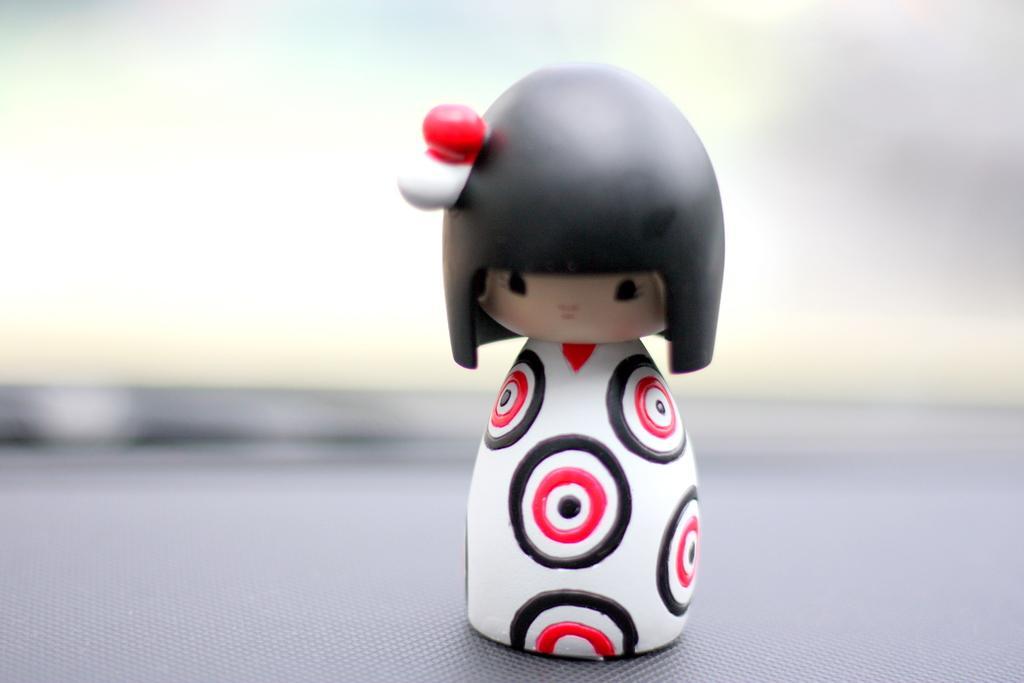Please provide a concise description of this image. There is a toy and the background of the toy is blur. 